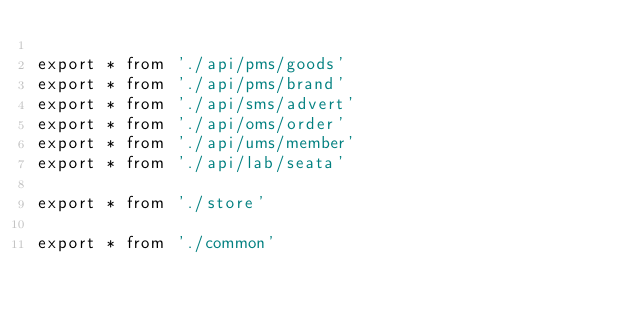<code> <loc_0><loc_0><loc_500><loc_500><_TypeScript_>
export * from './api/pms/goods'
export * from './api/pms/brand'
export * from './api/sms/advert'
export * from './api/oms/order'
export * from './api/ums/member'
export * from './api/lab/seata'

export * from './store'

export * from './common'

</code> 